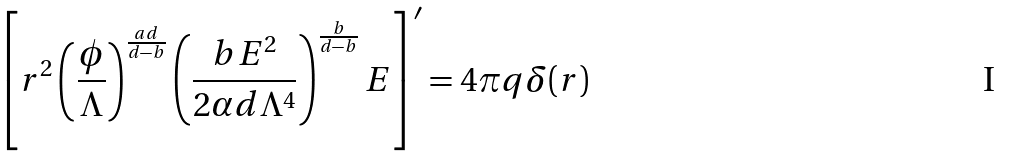<formula> <loc_0><loc_0><loc_500><loc_500>\left [ r ^ { 2 } \left ( \frac { \phi } { \Lambda } \right ) ^ { \frac { a d } { d - b } } \left ( \frac { b E ^ { 2 } } { 2 \alpha d \Lambda ^ { 4 } } \right ) ^ { \frac { b } { d - b } } E \right ] ^ { \prime } = 4 \pi q \delta ( r )</formula> 